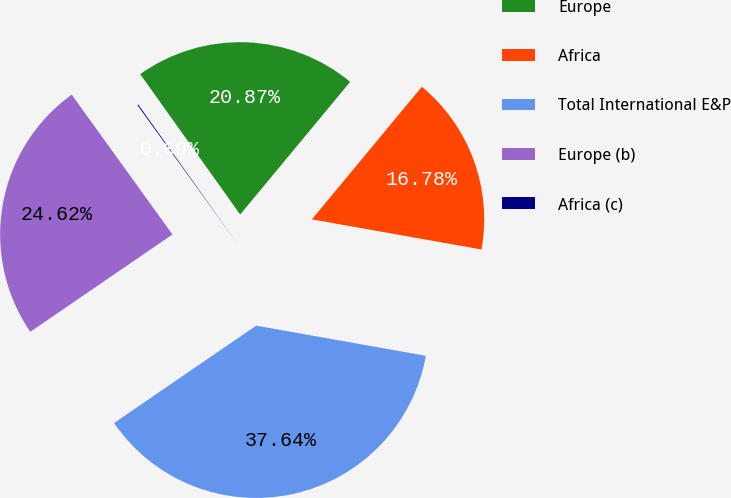<chart> <loc_0><loc_0><loc_500><loc_500><pie_chart><fcel>Europe<fcel>Africa<fcel>Total International E&P<fcel>Europe (b)<fcel>Africa (c)<nl><fcel>20.87%<fcel>16.78%<fcel>37.64%<fcel>24.62%<fcel>0.09%<nl></chart> 